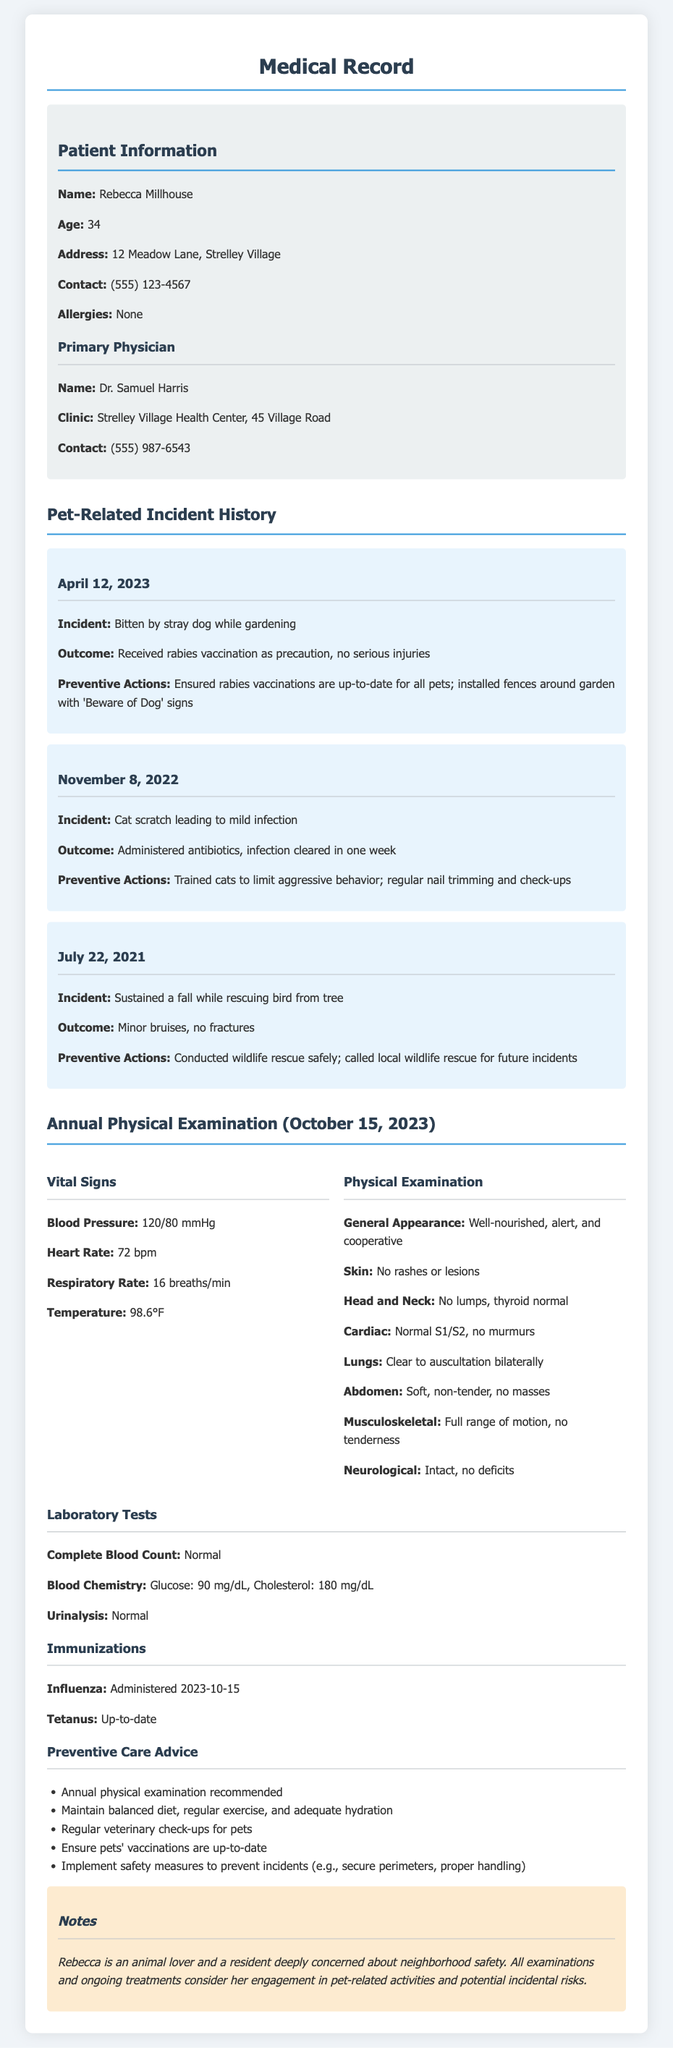What is the patient's name? The patient's name is listed at the top of the document under Patient Information.
Answer: Rebecca Millhouse What was the outcome of the incident on April 12, 2023? The outcome is stated in relation to the incident that occurred on that date.
Answer: Received rabies vaccination as precaution, no serious injuries What is the date of the annual physical examination? The date is specified in the section detailing the Annual Physical Examination.
Answer: October 15, 2023 What is the patient's blood pressure reading? The blood pressure is included in the vital signs section of the examination details.
Answer: 120/80 mmHg How many pet-related incidents are recorded in the document? The total number of incidents is found by counting the entries in the Pet-Related Incident History section.
Answer: Three What preventive action was taken after the cat scratch incident? The preventive action is noted in the context of the second incident.
Answer: Trained cats to limit aggressive behavior What immunization was administered on October 15, 2023? This information is detailed under the Immunizations section.
Answer: Influenza What does the notes section indicate about Rebecca's attitude towards animals? The notes provide insight into Rebecca's perspective regarding her involvement with pets.
Answer: Deeply concerned about neighborhood safety What should be implemented to prevent pet-related incidents? The details in the Preventive Care Advice section suggest safety measures.
Answer: Implement safety measures to prevent incidents 